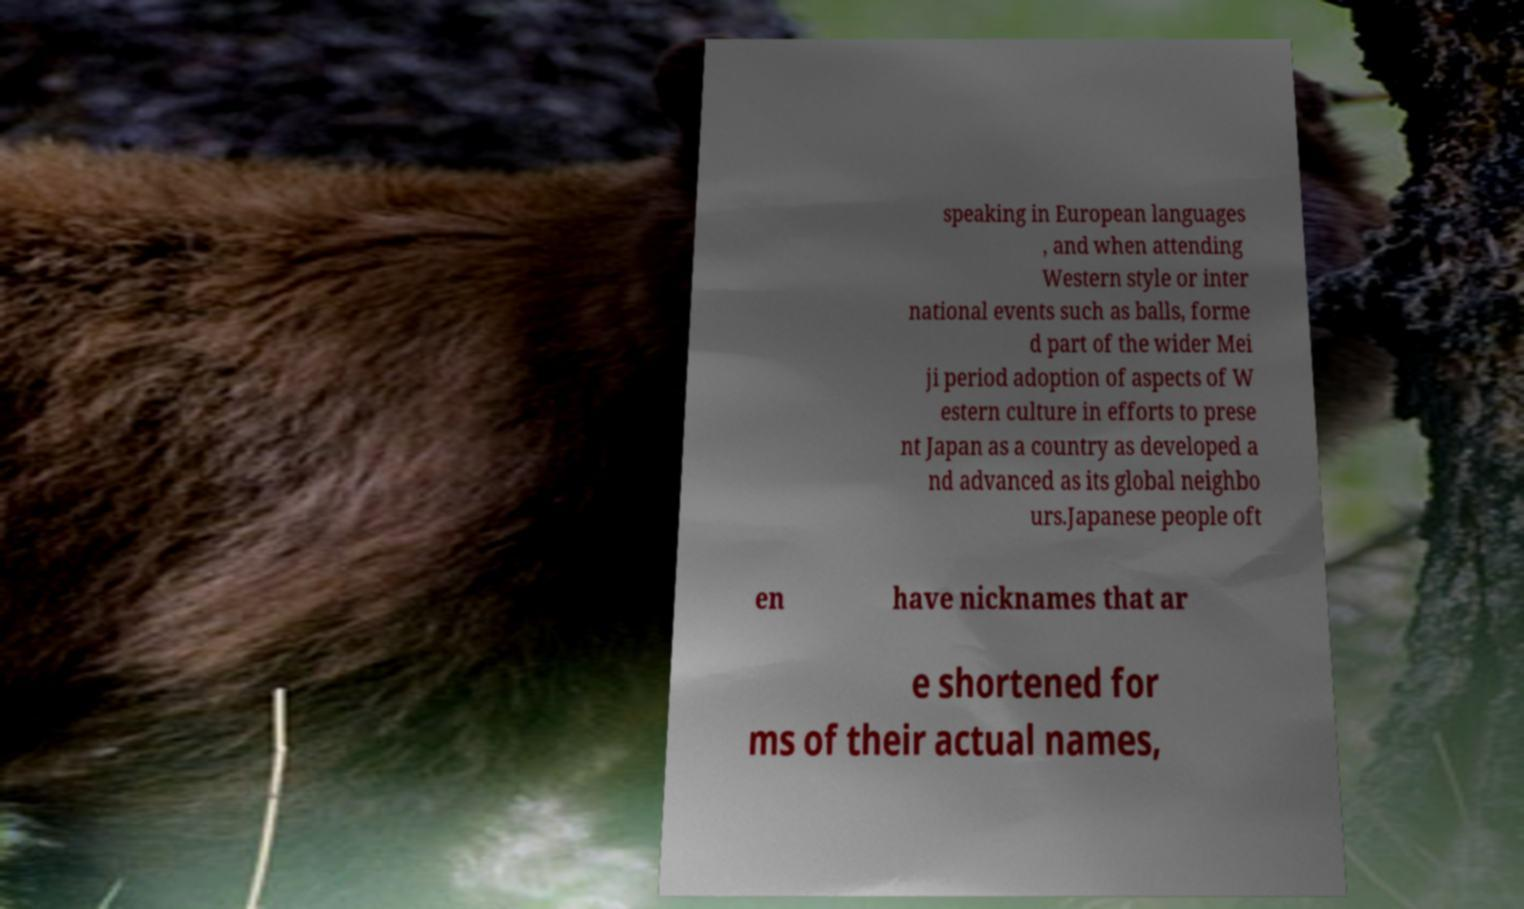Can you accurately transcribe the text from the provided image for me? speaking in European languages , and when attending Western style or inter national events such as balls, forme d part of the wider Mei ji period adoption of aspects of W estern culture in efforts to prese nt Japan as a country as developed a nd advanced as its global neighbo urs.Japanese people oft en have nicknames that ar e shortened for ms of their actual names, 